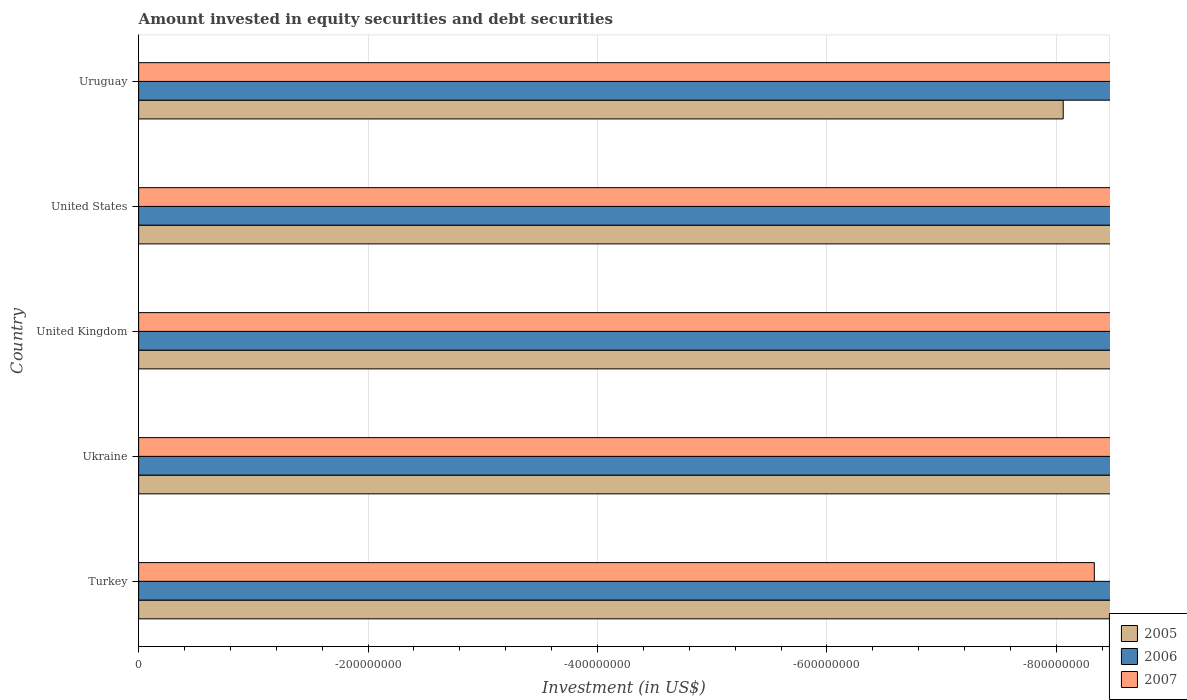How many different coloured bars are there?
Your answer should be compact. 0. Are the number of bars on each tick of the Y-axis equal?
Make the answer very short. Yes. What is the label of the 4th group of bars from the top?
Keep it short and to the point. Ukraine. In how many cases, is the number of bars for a given country not equal to the number of legend labels?
Your answer should be very brief. 5. What is the amount invested in equity securities and debt securities in 2007 in Turkey?
Offer a terse response. 0. Across all countries, what is the minimum amount invested in equity securities and debt securities in 2007?
Your answer should be compact. 0. What is the total amount invested in equity securities and debt securities in 2006 in the graph?
Provide a succinct answer. 0. In how many countries, is the amount invested in equity securities and debt securities in 2005 greater than -520000000 US$?
Your response must be concise. 0. In how many countries, is the amount invested in equity securities and debt securities in 2006 greater than the average amount invested in equity securities and debt securities in 2006 taken over all countries?
Make the answer very short. 0. Does the graph contain any zero values?
Offer a terse response. Yes. How many legend labels are there?
Your answer should be very brief. 3. What is the title of the graph?
Provide a short and direct response. Amount invested in equity securities and debt securities. What is the label or title of the X-axis?
Give a very brief answer. Investment (in US$). What is the label or title of the Y-axis?
Offer a terse response. Country. What is the Investment (in US$) of 2006 in Turkey?
Provide a succinct answer. 0. What is the Investment (in US$) of 2006 in Ukraine?
Keep it short and to the point. 0. What is the Investment (in US$) in 2005 in United Kingdom?
Your answer should be very brief. 0. What is the Investment (in US$) of 2005 in United States?
Your response must be concise. 0. What is the Investment (in US$) of 2007 in United States?
Offer a very short reply. 0. What is the total Investment (in US$) in 2006 in the graph?
Your response must be concise. 0. What is the total Investment (in US$) in 2007 in the graph?
Ensure brevity in your answer.  0. 